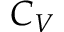Convert formula to latex. <formula><loc_0><loc_0><loc_500><loc_500>C _ { V }</formula> 